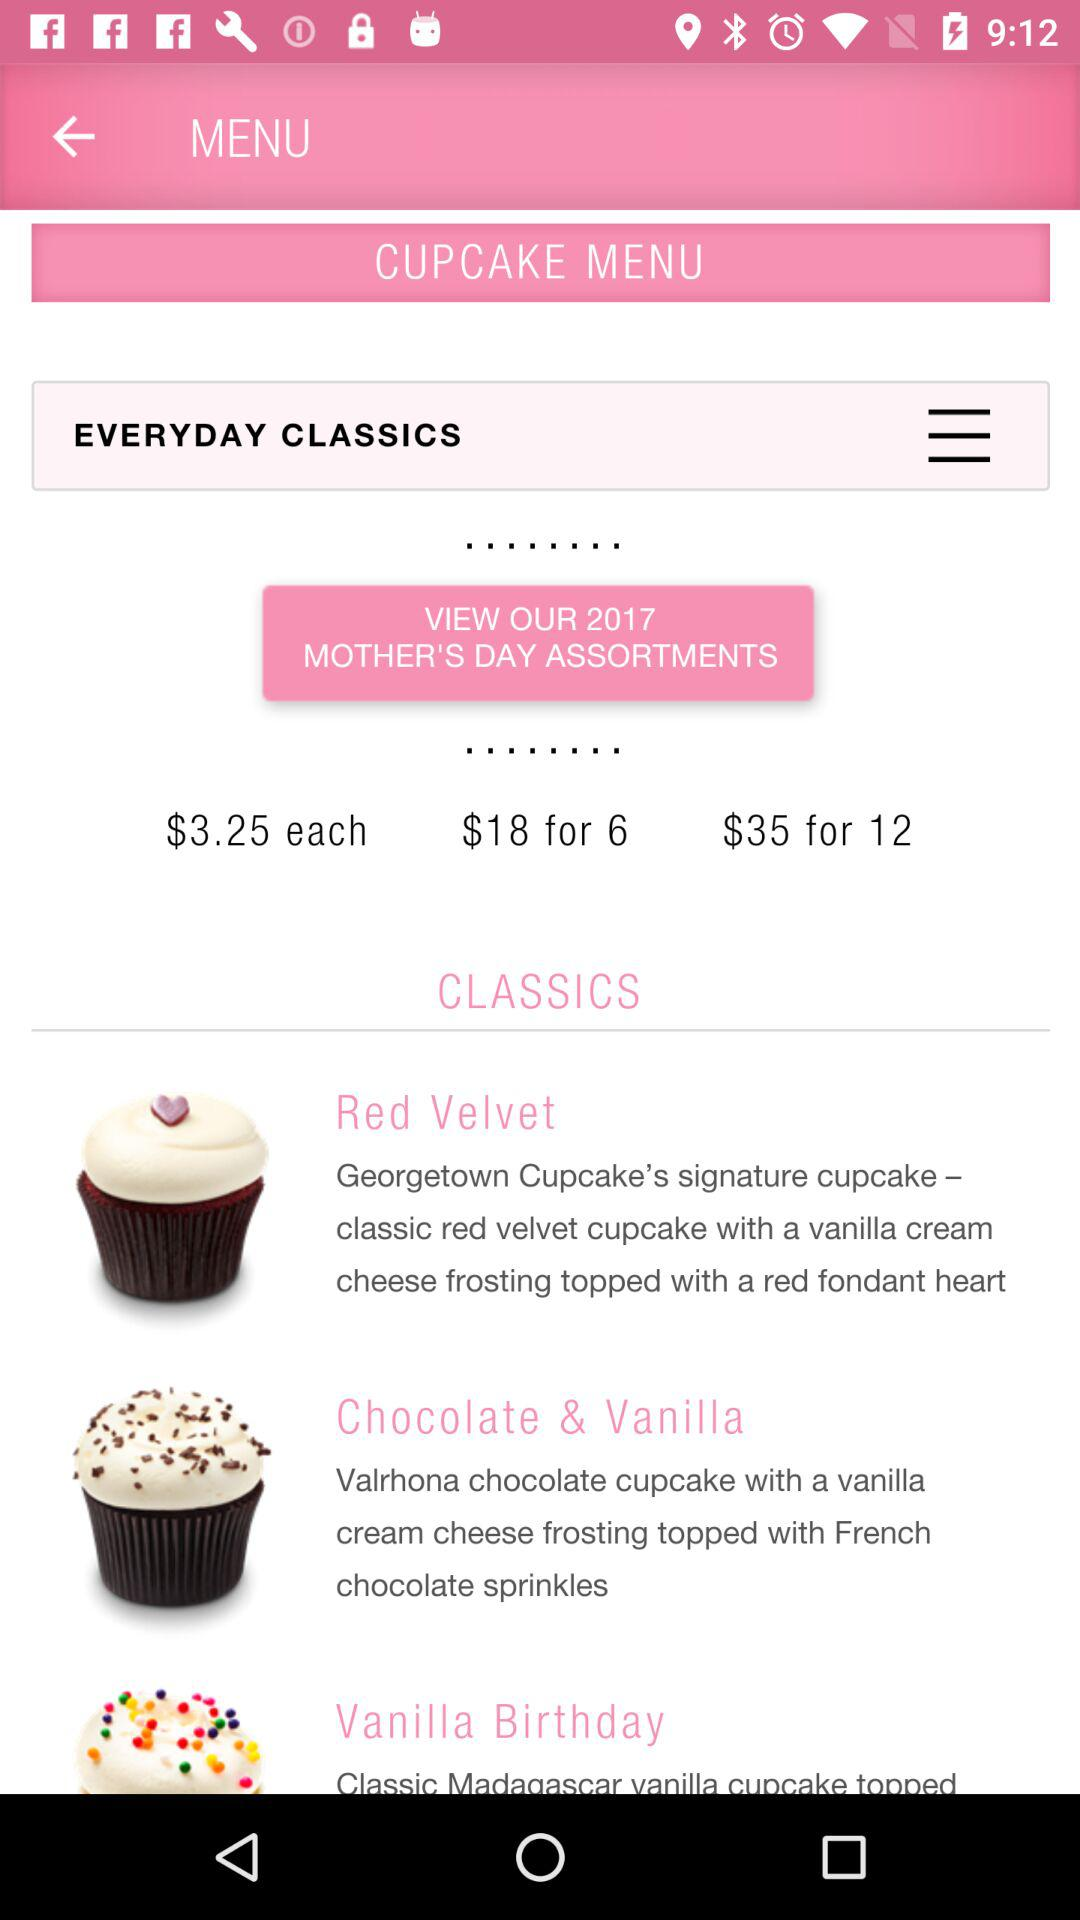How many cupcakes are there in the 'Everyday Classics' section?
Answer the question using a single word or phrase. 3 